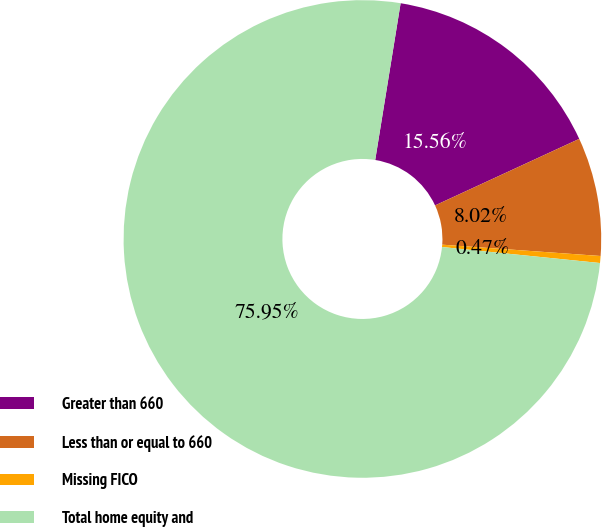Convert chart. <chart><loc_0><loc_0><loc_500><loc_500><pie_chart><fcel>Greater than 660<fcel>Less than or equal to 660<fcel>Missing FICO<fcel>Total home equity and<nl><fcel>15.56%<fcel>8.02%<fcel>0.47%<fcel>75.95%<nl></chart> 